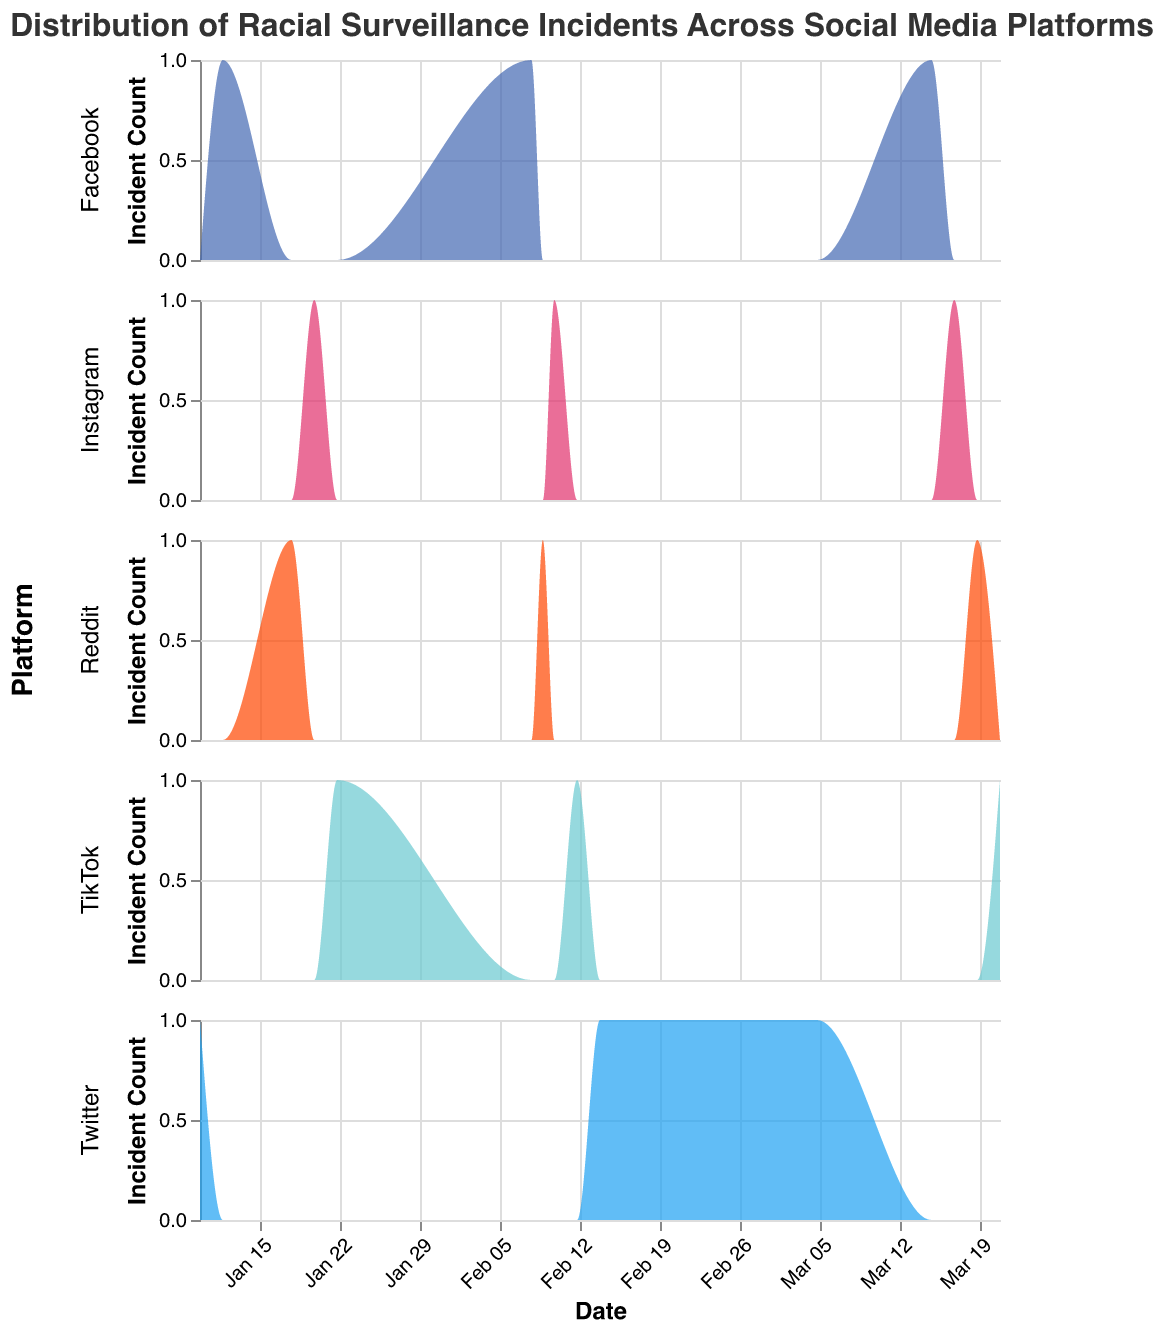What is the title of the figure? The title is displayed at the top of the figure. It reads "Distribution of Racial Surveillance Incidents Across Social Media Platforms".
Answer: Distribution of Racial Surveillance Incidents Across Social Media Platforms How many different platforms are shown in the figure? The figure facets the density plots by platform, and each row represents a different platform. The platforms are Twitter, Facebook, Instagram, Reddit, and TikTok.
Answer: 5 Which platform has the highest number of incidents in February 2023? By examining the February data points for each platform, Facebook has the highest count with 22 incidents.
Answer: Facebook What is the trend of incidents on TikTok over the three months displayed in the figure? Looking at the density plot for TikTok, the incident counts start at 10 in January, increase to 18 in February, and then slightly decrease to 16 in March.
Answer: Increasing then decreasing Comparing January 2023 data, which platform had the fewest incidents? By comparing the January incident counts for each platform, Reddit has the fewest incidents with a count of 8.
Answer: Reddit What was the total number of incidents reported on Facebook over the three months? Summing the incidents for Facebook: January (18), February (22), and March (16). 18 + 22 + 16 = 56 incidents.
Answer: 56 Which platform showed a consistent month-to-month increase in incidents over the period? By examining each platform, TikTok shows a consistent increase in incidents from January (10) to February (18), and then a slight increase to March (16). This indicates an increasing trend with a minor drop.
Answer: None What is the average number of incidents across all platforms in March 2023? Summing the incidents for March across all platforms then dividing by the number of platforms: Twitter (12), Facebook (16), Instagram (14), Reddit (10), TikTok (16). (12 + 16 + 14 + 10 + 16) / 5 = 13.6.
Answer: 13.6 In which month did Instagram have the highest number of incidents? By examining Instagram's data points, the highest number of incidents is in February with a count of 15.
Answer: February How does the incident trend on Reddit compare to Twitter over the three months? Comparing the density plots: Twitter has 15, 20, 12, while Reddit has 8, 12, 10 for January, February, and March, respectively. Reddit shows an overall lower count and smaller fluctuations compared to Twitter.
Answer: Lower and more stable 